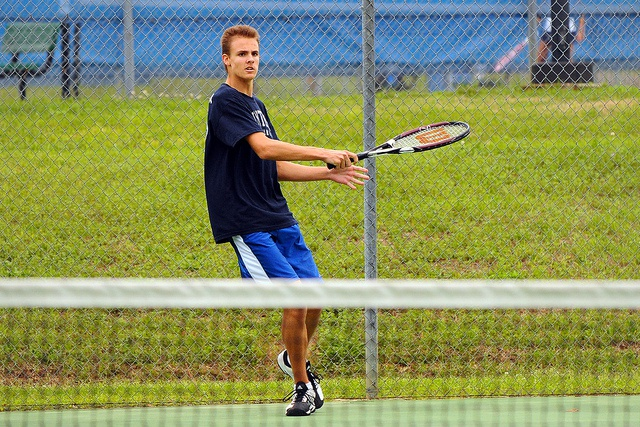Describe the objects in this image and their specific colors. I can see people in gray, black, lightgray, brown, and navy tones, bench in gray, teal, darkgray, and black tones, tennis racket in gray, lightgray, black, darkgray, and beige tones, and people in gray and darkgray tones in this image. 